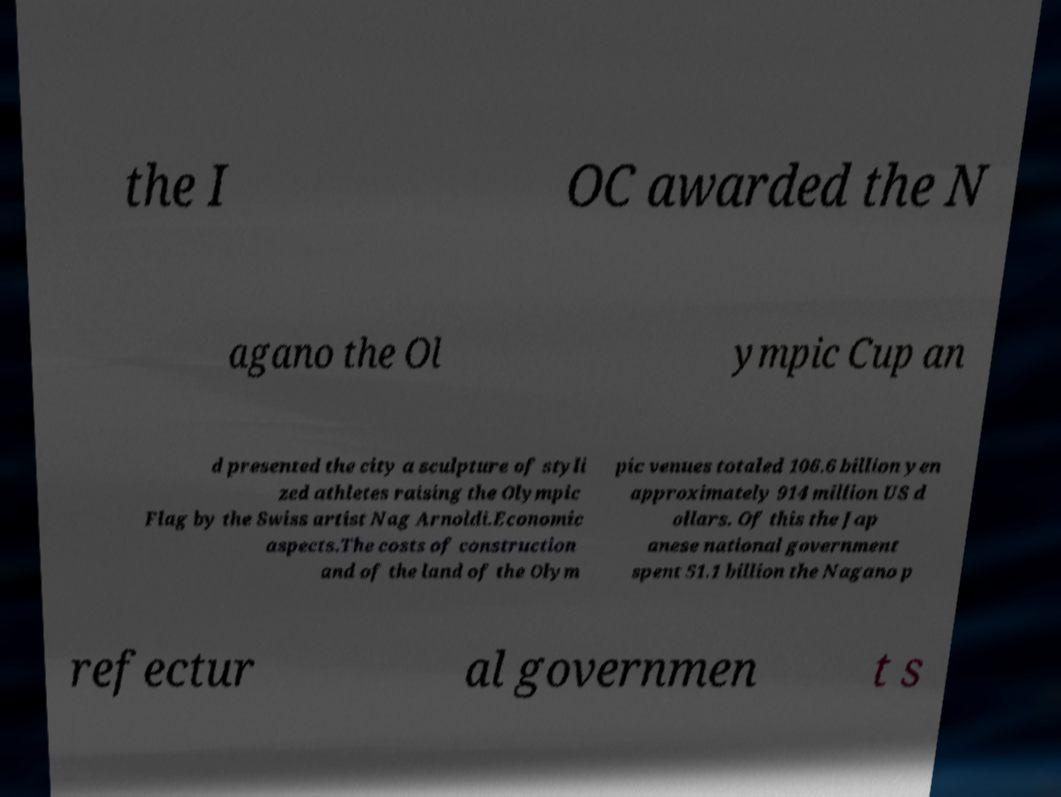There's text embedded in this image that I need extracted. Can you transcribe it verbatim? the I OC awarded the N agano the Ol ympic Cup an d presented the city a sculpture of styli zed athletes raising the Olympic Flag by the Swiss artist Nag Arnoldi.Economic aspects.The costs of construction and of the land of the Olym pic venues totaled 106.6 billion yen approximately 914 million US d ollars. Of this the Jap anese national government spent 51.1 billion the Nagano p refectur al governmen t s 